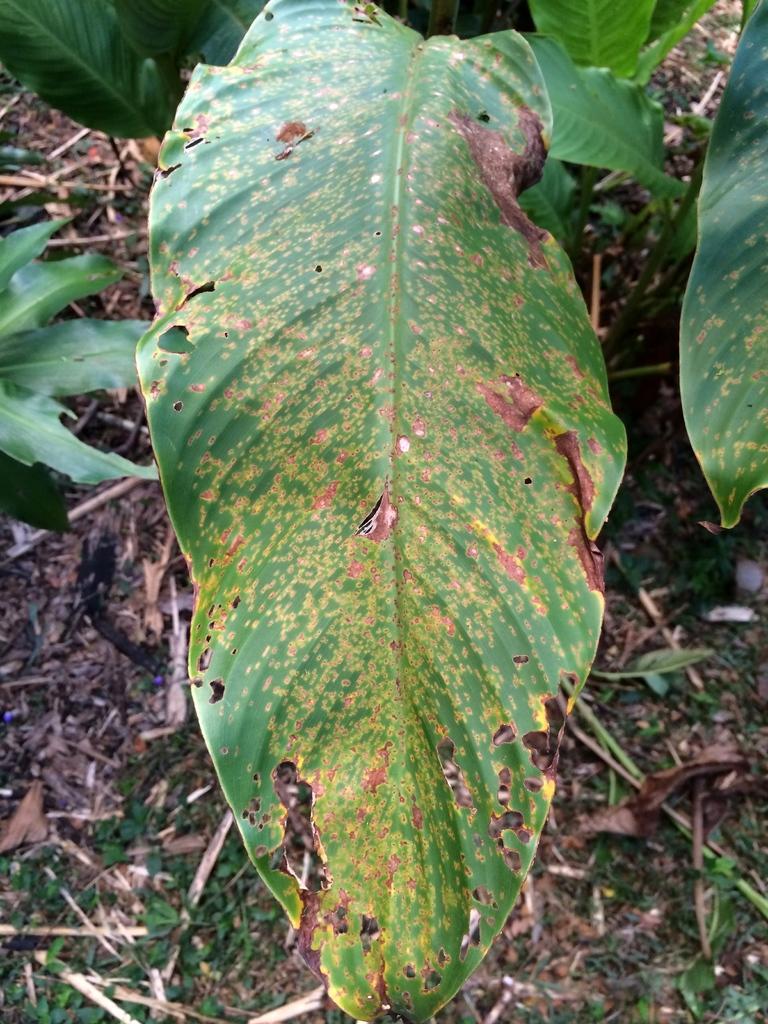Describe this image in one or two sentences. In this image, in the middle, we can see a leaf which is in green color. On the right side, we can also see a leaf. On the left side, we can see a plant. In the background, we can see green color. At the bottom, we can see a land with some leaves. 